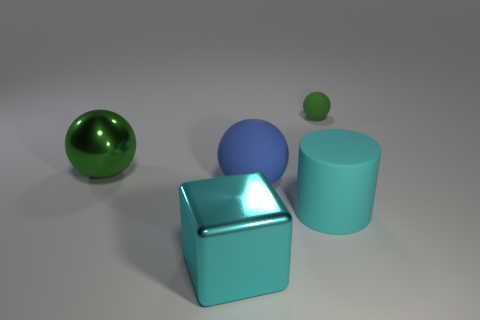Subtract all matte balls. How many balls are left? 1 Subtract all green spheres. How many spheres are left? 1 Add 5 big blue spheres. How many objects exist? 10 Subtract 1 spheres. How many spheres are left? 2 Subtract all red cubes. How many blue spheres are left? 1 Subtract all tiny red cylinders. Subtract all big matte balls. How many objects are left? 4 Add 4 big cylinders. How many big cylinders are left? 5 Add 4 big red objects. How many big red objects exist? 4 Subtract 0 yellow cylinders. How many objects are left? 5 Subtract all cylinders. How many objects are left? 4 